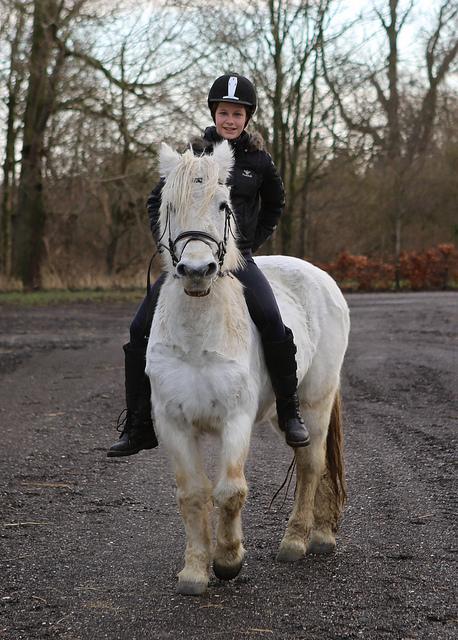What kind of shoes is the woman wearing?
Short answer required. Boots. Is this horse wild?
Give a very brief answer. No. Are the persons on top of the horse acrobats?
Write a very short answer. No. What color is the person's suit?
Be succinct. Black. What animal is in the picture?
Short answer required. Horse. Who is on the horse's back?
Answer briefly. Girl. What is the horse eating?
Be succinct. Nothing. What is the color of the horse?
Give a very brief answer. White. 